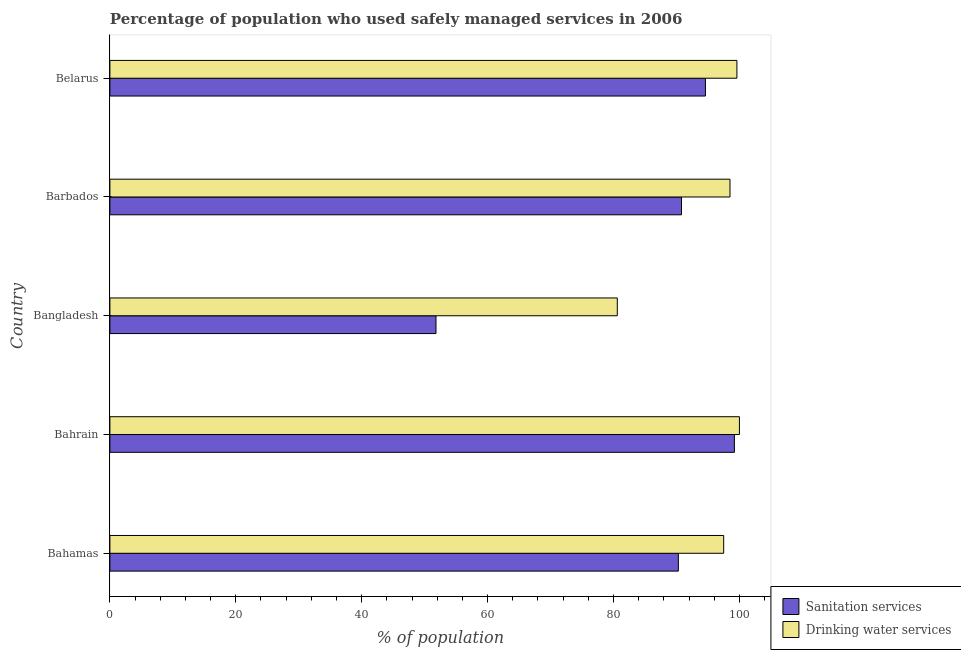Are the number of bars on each tick of the Y-axis equal?
Offer a terse response. Yes. What is the label of the 4th group of bars from the top?
Offer a very short reply. Bahrain. What is the percentage of population who used sanitation services in Bahamas?
Keep it short and to the point. 90.3. Across all countries, what is the maximum percentage of population who used drinking water services?
Offer a terse response. 100. Across all countries, what is the minimum percentage of population who used drinking water services?
Your answer should be compact. 80.6. In which country was the percentage of population who used sanitation services maximum?
Provide a short and direct response. Bahrain. In which country was the percentage of population who used sanitation services minimum?
Make the answer very short. Bangladesh. What is the total percentage of population who used sanitation services in the graph?
Your response must be concise. 426.7. What is the difference between the percentage of population who used sanitation services in Bahamas and that in Bangladesh?
Keep it short and to the point. 38.5. What is the difference between the percentage of population who used sanitation services in Bahrain and the percentage of population who used drinking water services in Barbados?
Give a very brief answer. 0.7. What is the average percentage of population who used sanitation services per country?
Ensure brevity in your answer.  85.34. What is the difference between the percentage of population who used drinking water services and percentage of population who used sanitation services in Bahamas?
Provide a succinct answer. 7.2. What is the ratio of the percentage of population who used sanitation services in Bahrain to that in Belarus?
Your answer should be compact. 1.05. Is the percentage of population who used drinking water services in Bahamas less than that in Bahrain?
Offer a terse response. Yes. What is the difference between the highest and the lowest percentage of population who used sanitation services?
Provide a short and direct response. 47.4. What does the 1st bar from the top in Barbados represents?
Ensure brevity in your answer.  Drinking water services. What does the 2nd bar from the bottom in Bahamas represents?
Provide a succinct answer. Drinking water services. How many bars are there?
Ensure brevity in your answer.  10. How many countries are there in the graph?
Offer a terse response. 5. What is the difference between two consecutive major ticks on the X-axis?
Your answer should be very brief. 20. Are the values on the major ticks of X-axis written in scientific E-notation?
Your answer should be very brief. No. Does the graph contain grids?
Give a very brief answer. No. Where does the legend appear in the graph?
Your answer should be very brief. Bottom right. What is the title of the graph?
Your answer should be very brief. Percentage of population who used safely managed services in 2006. What is the label or title of the X-axis?
Provide a short and direct response. % of population. What is the % of population in Sanitation services in Bahamas?
Make the answer very short. 90.3. What is the % of population of Drinking water services in Bahamas?
Ensure brevity in your answer.  97.5. What is the % of population in Sanitation services in Bahrain?
Provide a short and direct response. 99.2. What is the % of population in Sanitation services in Bangladesh?
Make the answer very short. 51.8. What is the % of population of Drinking water services in Bangladesh?
Your answer should be very brief. 80.6. What is the % of population of Sanitation services in Barbados?
Offer a terse response. 90.8. What is the % of population in Drinking water services in Barbados?
Give a very brief answer. 98.5. What is the % of population in Sanitation services in Belarus?
Offer a terse response. 94.6. What is the % of population in Drinking water services in Belarus?
Provide a succinct answer. 99.6. Across all countries, what is the maximum % of population of Sanitation services?
Your answer should be compact. 99.2. Across all countries, what is the maximum % of population in Drinking water services?
Provide a succinct answer. 100. Across all countries, what is the minimum % of population of Sanitation services?
Provide a succinct answer. 51.8. Across all countries, what is the minimum % of population of Drinking water services?
Keep it short and to the point. 80.6. What is the total % of population in Sanitation services in the graph?
Provide a succinct answer. 426.7. What is the total % of population of Drinking water services in the graph?
Your response must be concise. 476.2. What is the difference between the % of population in Drinking water services in Bahamas and that in Bahrain?
Your answer should be very brief. -2.5. What is the difference between the % of population in Sanitation services in Bahamas and that in Bangladesh?
Keep it short and to the point. 38.5. What is the difference between the % of population in Sanitation services in Bahamas and that in Barbados?
Give a very brief answer. -0.5. What is the difference between the % of population in Drinking water services in Bahamas and that in Belarus?
Offer a very short reply. -2.1. What is the difference between the % of population of Sanitation services in Bahrain and that in Bangladesh?
Offer a very short reply. 47.4. What is the difference between the % of population of Drinking water services in Bahrain and that in Belarus?
Make the answer very short. 0.4. What is the difference between the % of population of Sanitation services in Bangladesh and that in Barbados?
Make the answer very short. -39. What is the difference between the % of population of Drinking water services in Bangladesh and that in Barbados?
Offer a terse response. -17.9. What is the difference between the % of population of Sanitation services in Bangladesh and that in Belarus?
Your answer should be compact. -42.8. What is the difference between the % of population in Drinking water services in Bangladesh and that in Belarus?
Your answer should be compact. -19. What is the difference between the % of population of Sanitation services in Bahamas and the % of population of Drinking water services in Bangladesh?
Give a very brief answer. 9.7. What is the difference between the % of population in Sanitation services in Bahamas and the % of population in Drinking water services in Barbados?
Your answer should be very brief. -8.2. What is the difference between the % of population in Sanitation services in Bahrain and the % of population in Drinking water services in Belarus?
Your answer should be very brief. -0.4. What is the difference between the % of population in Sanitation services in Bangladesh and the % of population in Drinking water services in Barbados?
Make the answer very short. -46.7. What is the difference between the % of population of Sanitation services in Bangladesh and the % of population of Drinking water services in Belarus?
Offer a terse response. -47.8. What is the average % of population in Sanitation services per country?
Offer a terse response. 85.34. What is the average % of population in Drinking water services per country?
Give a very brief answer. 95.24. What is the difference between the % of population in Sanitation services and % of population in Drinking water services in Bahamas?
Provide a short and direct response. -7.2. What is the difference between the % of population in Sanitation services and % of population in Drinking water services in Bangladesh?
Ensure brevity in your answer.  -28.8. What is the ratio of the % of population of Sanitation services in Bahamas to that in Bahrain?
Offer a terse response. 0.91. What is the ratio of the % of population of Drinking water services in Bahamas to that in Bahrain?
Your answer should be compact. 0.97. What is the ratio of the % of population of Sanitation services in Bahamas to that in Bangladesh?
Your response must be concise. 1.74. What is the ratio of the % of population of Drinking water services in Bahamas to that in Bangladesh?
Provide a short and direct response. 1.21. What is the ratio of the % of population of Drinking water services in Bahamas to that in Barbados?
Make the answer very short. 0.99. What is the ratio of the % of population of Sanitation services in Bahamas to that in Belarus?
Offer a very short reply. 0.95. What is the ratio of the % of population of Drinking water services in Bahamas to that in Belarus?
Provide a short and direct response. 0.98. What is the ratio of the % of population of Sanitation services in Bahrain to that in Bangladesh?
Offer a terse response. 1.92. What is the ratio of the % of population of Drinking water services in Bahrain to that in Bangladesh?
Offer a terse response. 1.24. What is the ratio of the % of population in Sanitation services in Bahrain to that in Barbados?
Your answer should be compact. 1.09. What is the ratio of the % of population in Drinking water services in Bahrain to that in Barbados?
Provide a short and direct response. 1.02. What is the ratio of the % of population of Sanitation services in Bahrain to that in Belarus?
Your answer should be very brief. 1.05. What is the ratio of the % of population of Drinking water services in Bahrain to that in Belarus?
Your response must be concise. 1. What is the ratio of the % of population in Sanitation services in Bangladesh to that in Barbados?
Keep it short and to the point. 0.57. What is the ratio of the % of population in Drinking water services in Bangladesh to that in Barbados?
Your response must be concise. 0.82. What is the ratio of the % of population of Sanitation services in Bangladesh to that in Belarus?
Offer a terse response. 0.55. What is the ratio of the % of population of Drinking water services in Bangladesh to that in Belarus?
Provide a succinct answer. 0.81. What is the ratio of the % of population in Sanitation services in Barbados to that in Belarus?
Give a very brief answer. 0.96. What is the difference between the highest and the second highest % of population in Drinking water services?
Your answer should be very brief. 0.4. What is the difference between the highest and the lowest % of population in Sanitation services?
Your answer should be compact. 47.4. 